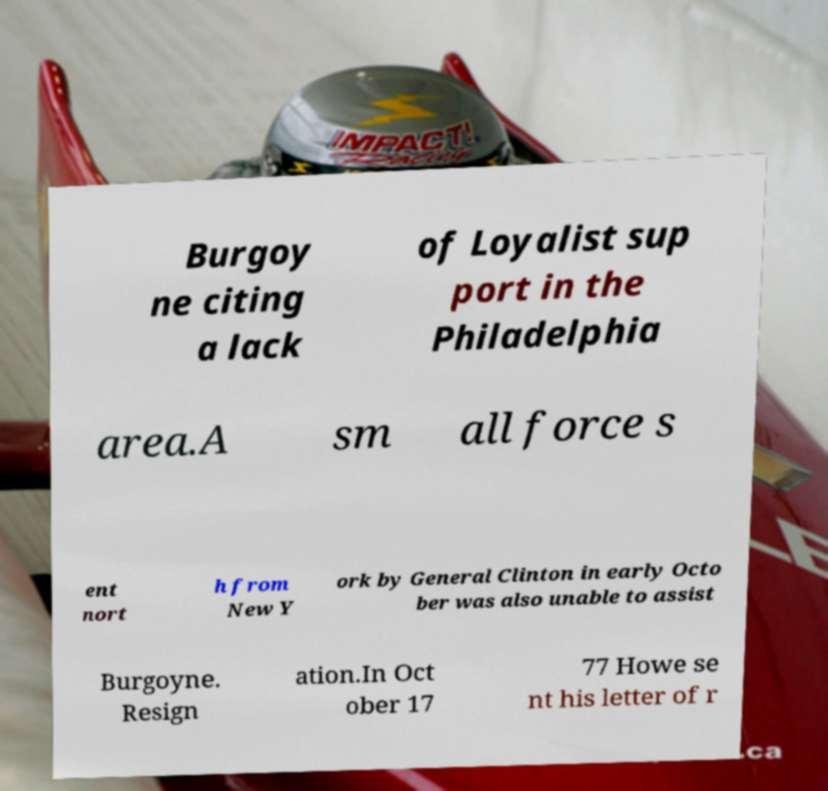Could you assist in decoding the text presented in this image and type it out clearly? Burgoy ne citing a lack of Loyalist sup port in the Philadelphia area.A sm all force s ent nort h from New Y ork by General Clinton in early Octo ber was also unable to assist Burgoyne. Resign ation.In Oct ober 17 77 Howe se nt his letter of r 